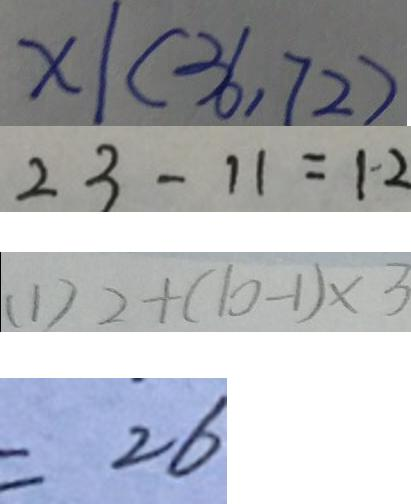<formula> <loc_0><loc_0><loc_500><loc_500>x \vert ( 3 6 , 7 2 ) 
 2 3 - 1 1 = 1 2 
 ( 1 ) 2 + ( 1 0 - 1 ) \times 3 
 = 2 6</formula> 